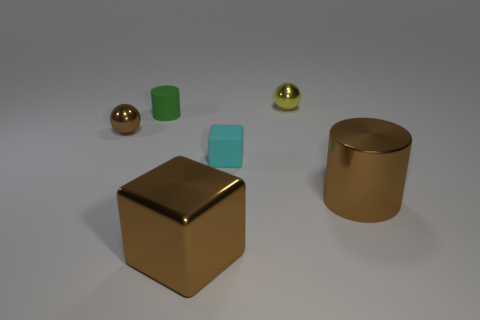Are there an equal number of green matte things behind the yellow metallic ball and tiny green cylinders that are on the right side of the brown metallic cylinder?
Give a very brief answer. Yes. What is the color of the large thing to the left of the yellow metal object?
Offer a very short reply. Brown. The big thing that is in front of the cylinder right of the small cyan cube is made of what material?
Provide a short and direct response. Metal. Are there fewer yellow spheres in front of the tiny cyan thing than small brown metallic things that are behind the brown metal cylinder?
Offer a very short reply. Yes. Do the metal cylinder and the tiny cylinder have the same color?
Keep it short and to the point. No. What color is the other small shiny thing that is the same shape as the tiny brown object?
Ensure brevity in your answer.  Yellow. Does the big cylinder have the same material as the small ball that is on the right side of the tiny brown object?
Make the answer very short. Yes. There is a rubber thing in front of the small metal sphere in front of the yellow shiny ball; what is its shape?
Give a very brief answer. Cube. There is a thing that is to the left of the green cylinder; does it have the same size as the tiny matte cylinder?
Make the answer very short. Yes. What number of other things are there of the same shape as the tiny green object?
Keep it short and to the point. 1. 